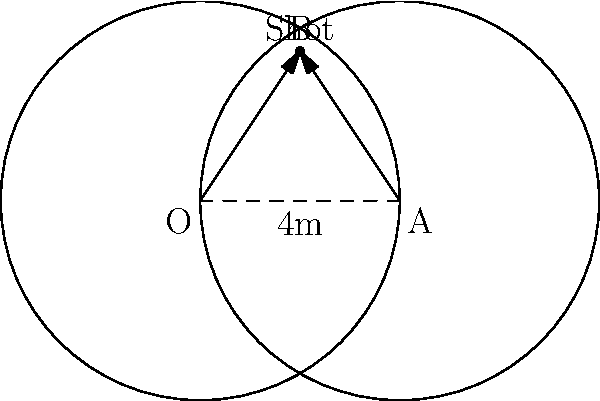A goalkeeper is positioned at point O, and their maximum reach is represented by a circle with a radius of 4 meters. An opposing player at point A, also 4 meters away, takes a shot that travels along the path AB. If the ball's trajectory intersects both circles at point B, what is the distance OB (the goalkeeper's required reach to save the shot)? Let's approach this step-by-step:

1) We have two circles: 
   Circle 1 centered at O with radius 4m
   Circle 2 centered at A with radius 4m

2) Point B is on both circles, forming two right-angled triangles: OBC and ABC

3) In triangle OAB:
   - OA = 4m (given)
   - OB = x (what we're solving for)
   - AB = 4m (radius of circle centered at A)

4) We can use the Pythagorean theorem in triangle OAB:

   $$OA^2 + OB^2 = AB^2$$
   $$4^2 + x^2 = 4^2$$
   $$16 + x^2 = 16$$

5) Simplifying:
   $$x^2 = 16 - 16 = 0$$
   $$x = \sqrt{0} = 0$$

6) However, x cannot be 0 as the ball clearly travels some distance. This means OB must equal OA, which is 4m.
Answer: 4 meters 